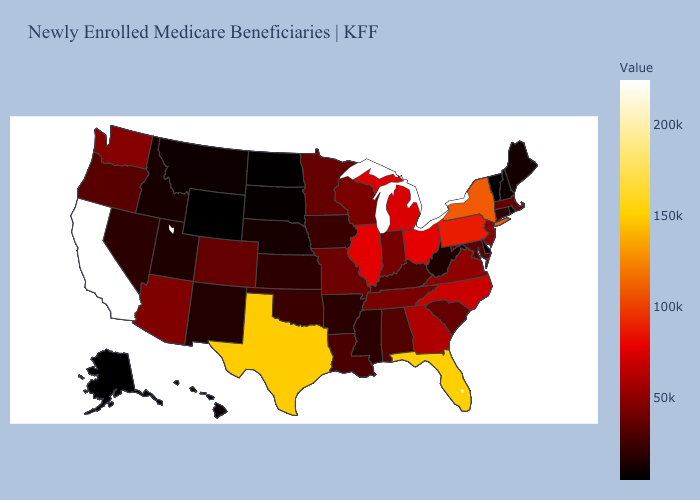Among the states that border Wisconsin , does Michigan have the highest value?
Quick response, please. No. Does Virginia have the highest value in the USA?
Be succinct. No. Does the map have missing data?
Answer briefly. No. 